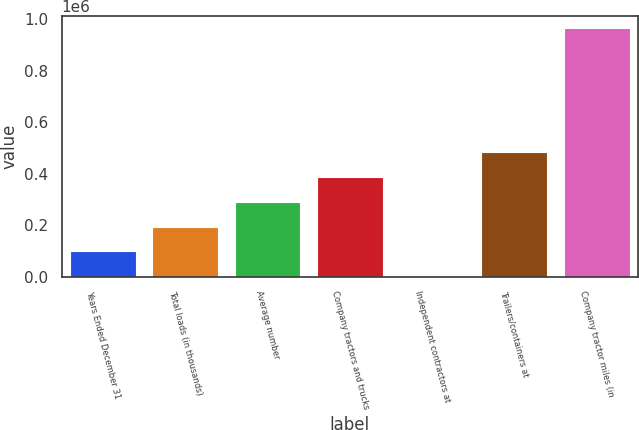<chart> <loc_0><loc_0><loc_500><loc_500><bar_chart><fcel>Years Ended December 31<fcel>Total loads (in thousands)<fcel>Average number<fcel>Company tractors and trucks<fcel>Independent contractors at<fcel>Trailers/containers at<fcel>Company tractor miles (in<nl><fcel>97489.9<fcel>193873<fcel>290256<fcel>386639<fcel>1107<fcel>483022<fcel>964936<nl></chart> 